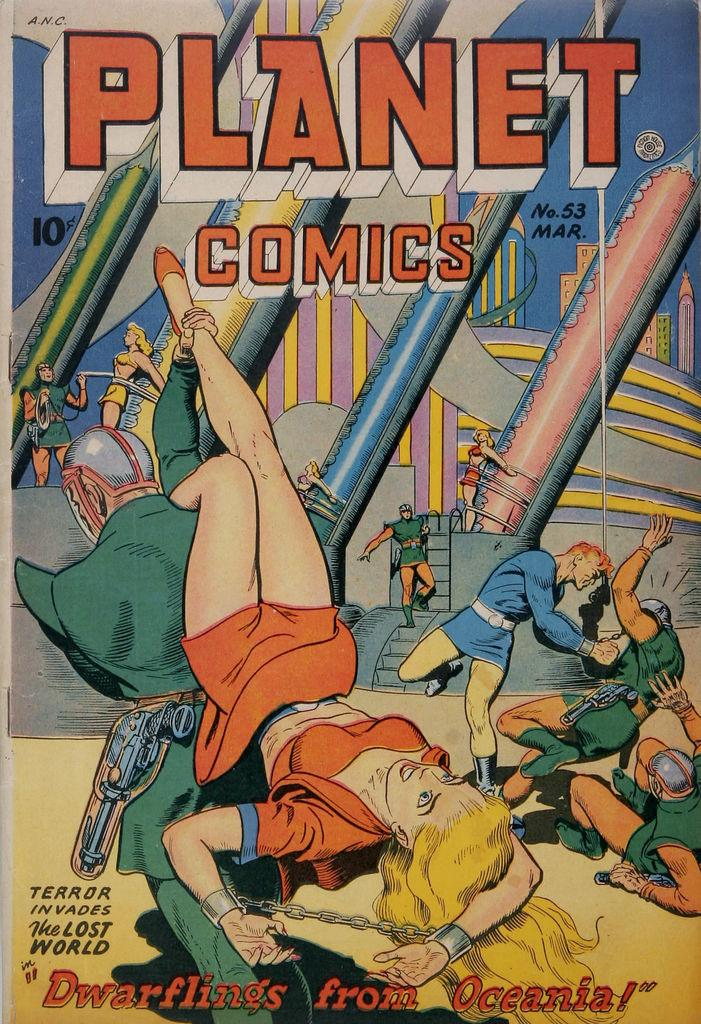<image>
Provide a brief description of the given image. A colorful Planet Comics cover with the title Dwarflings from Oceania written at the bottom. 